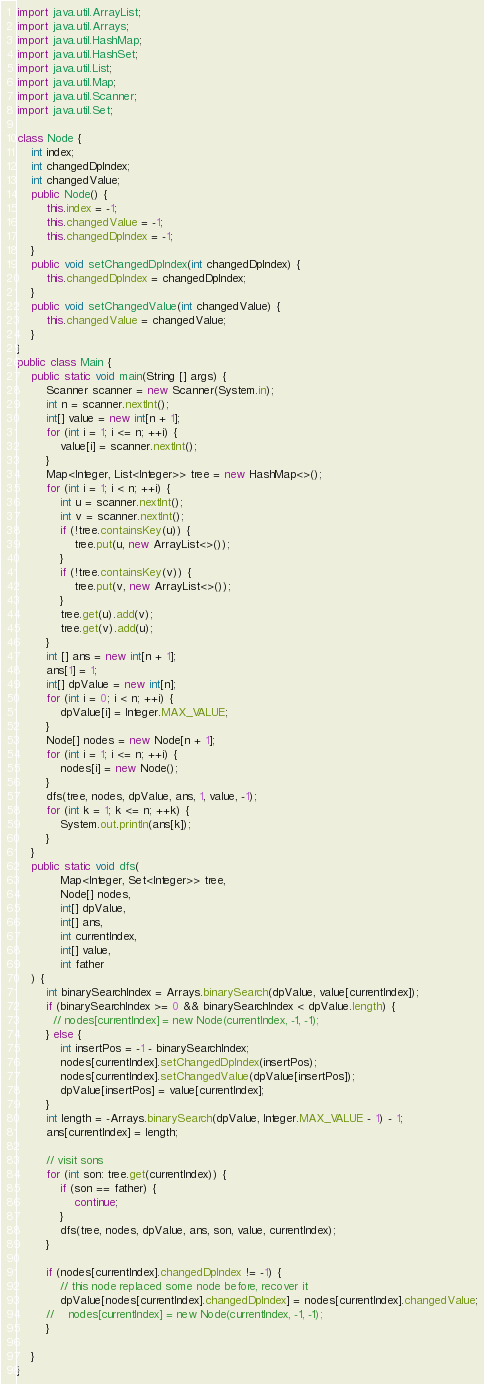<code> <loc_0><loc_0><loc_500><loc_500><_Java_>
import java.util.ArrayList;
import java.util.Arrays;
import java.util.HashMap;
import java.util.HashSet;
import java.util.List;
import java.util.Map;
import java.util.Scanner;
import java.util.Set;

class Node {
    int index;
    int changedDpIndex;
    int changedValue;
    public Node() {
        this.index = -1;
        this.changedValue = -1;
        this.changedDpIndex = -1;
    }
    public void setChangedDpIndex(int changedDpIndex) {
        this.changedDpIndex = changedDpIndex;
    }
    public void setChangedValue(int changedValue) {
        this.changedValue = changedValue;
    }
}
public class Main {
    public static void main(String [] args) {
        Scanner scanner = new Scanner(System.in);
        int n = scanner.nextInt();
        int[] value = new int[n + 1];
        for (int i = 1; i <= n; ++i) {
            value[i] = scanner.nextInt();
        }
        Map<Integer, List<Integer>> tree = new HashMap<>();
        for (int i = 1; i < n; ++i) {
            int u = scanner.nextInt();
            int v = scanner.nextInt();
            if (!tree.containsKey(u)) {
                tree.put(u, new ArrayList<>());
            }
            if (!tree.containsKey(v)) {
                tree.put(v, new ArrayList<>());
            }
            tree.get(u).add(v);
            tree.get(v).add(u);
        }
        int [] ans = new int[n + 1];
        ans[1] = 1;
        int[] dpValue = new int[n];
        for (int i = 0; i < n; ++i) {
            dpValue[i] = Integer.MAX_VALUE;
        }
        Node[] nodes = new Node[n + 1];
        for (int i = 1; i <= n; ++i) {
            nodes[i] = new Node();
        }
        dfs(tree, nodes, dpValue, ans, 1, value, -1);
        for (int k = 1; k <= n; ++k) {
            System.out.println(ans[k]);
        }
    }
    public static void dfs(
            Map<Integer, Set<Integer>> tree,
            Node[] nodes,
            int[] dpValue,
            int[] ans,
            int currentIndex,
            int[] value,
            int father
    ) {
        int binarySearchIndex = Arrays.binarySearch(dpValue, value[currentIndex]);
        if (binarySearchIndex >= 0 && binarySearchIndex < dpValue.length) {
          // nodes[currentIndex] = new Node(currentIndex, -1, -1);
        } else {
            int insertPos = -1 - binarySearchIndex;
            nodes[currentIndex].setChangedDpIndex(insertPos);
            nodes[currentIndex].setChangedValue(dpValue[insertPos]);
            dpValue[insertPos] = value[currentIndex];
        }
        int length = -Arrays.binarySearch(dpValue, Integer.MAX_VALUE - 1) - 1;
        ans[currentIndex] = length;

        // visit sons
        for (int son: tree.get(currentIndex)) {
            if (son == father) {
                continue;
            }
            dfs(tree, nodes, dpValue, ans, son, value, currentIndex);
        }

        if (nodes[currentIndex].changedDpIndex != -1) {
            // this node replaced some node before, recover it
            dpValue[nodes[currentIndex].changedDpIndex] = nodes[currentIndex].changedValue;
        //    nodes[currentIndex] = new Node(currentIndex, -1, -1);
        }

    }
}
</code> 